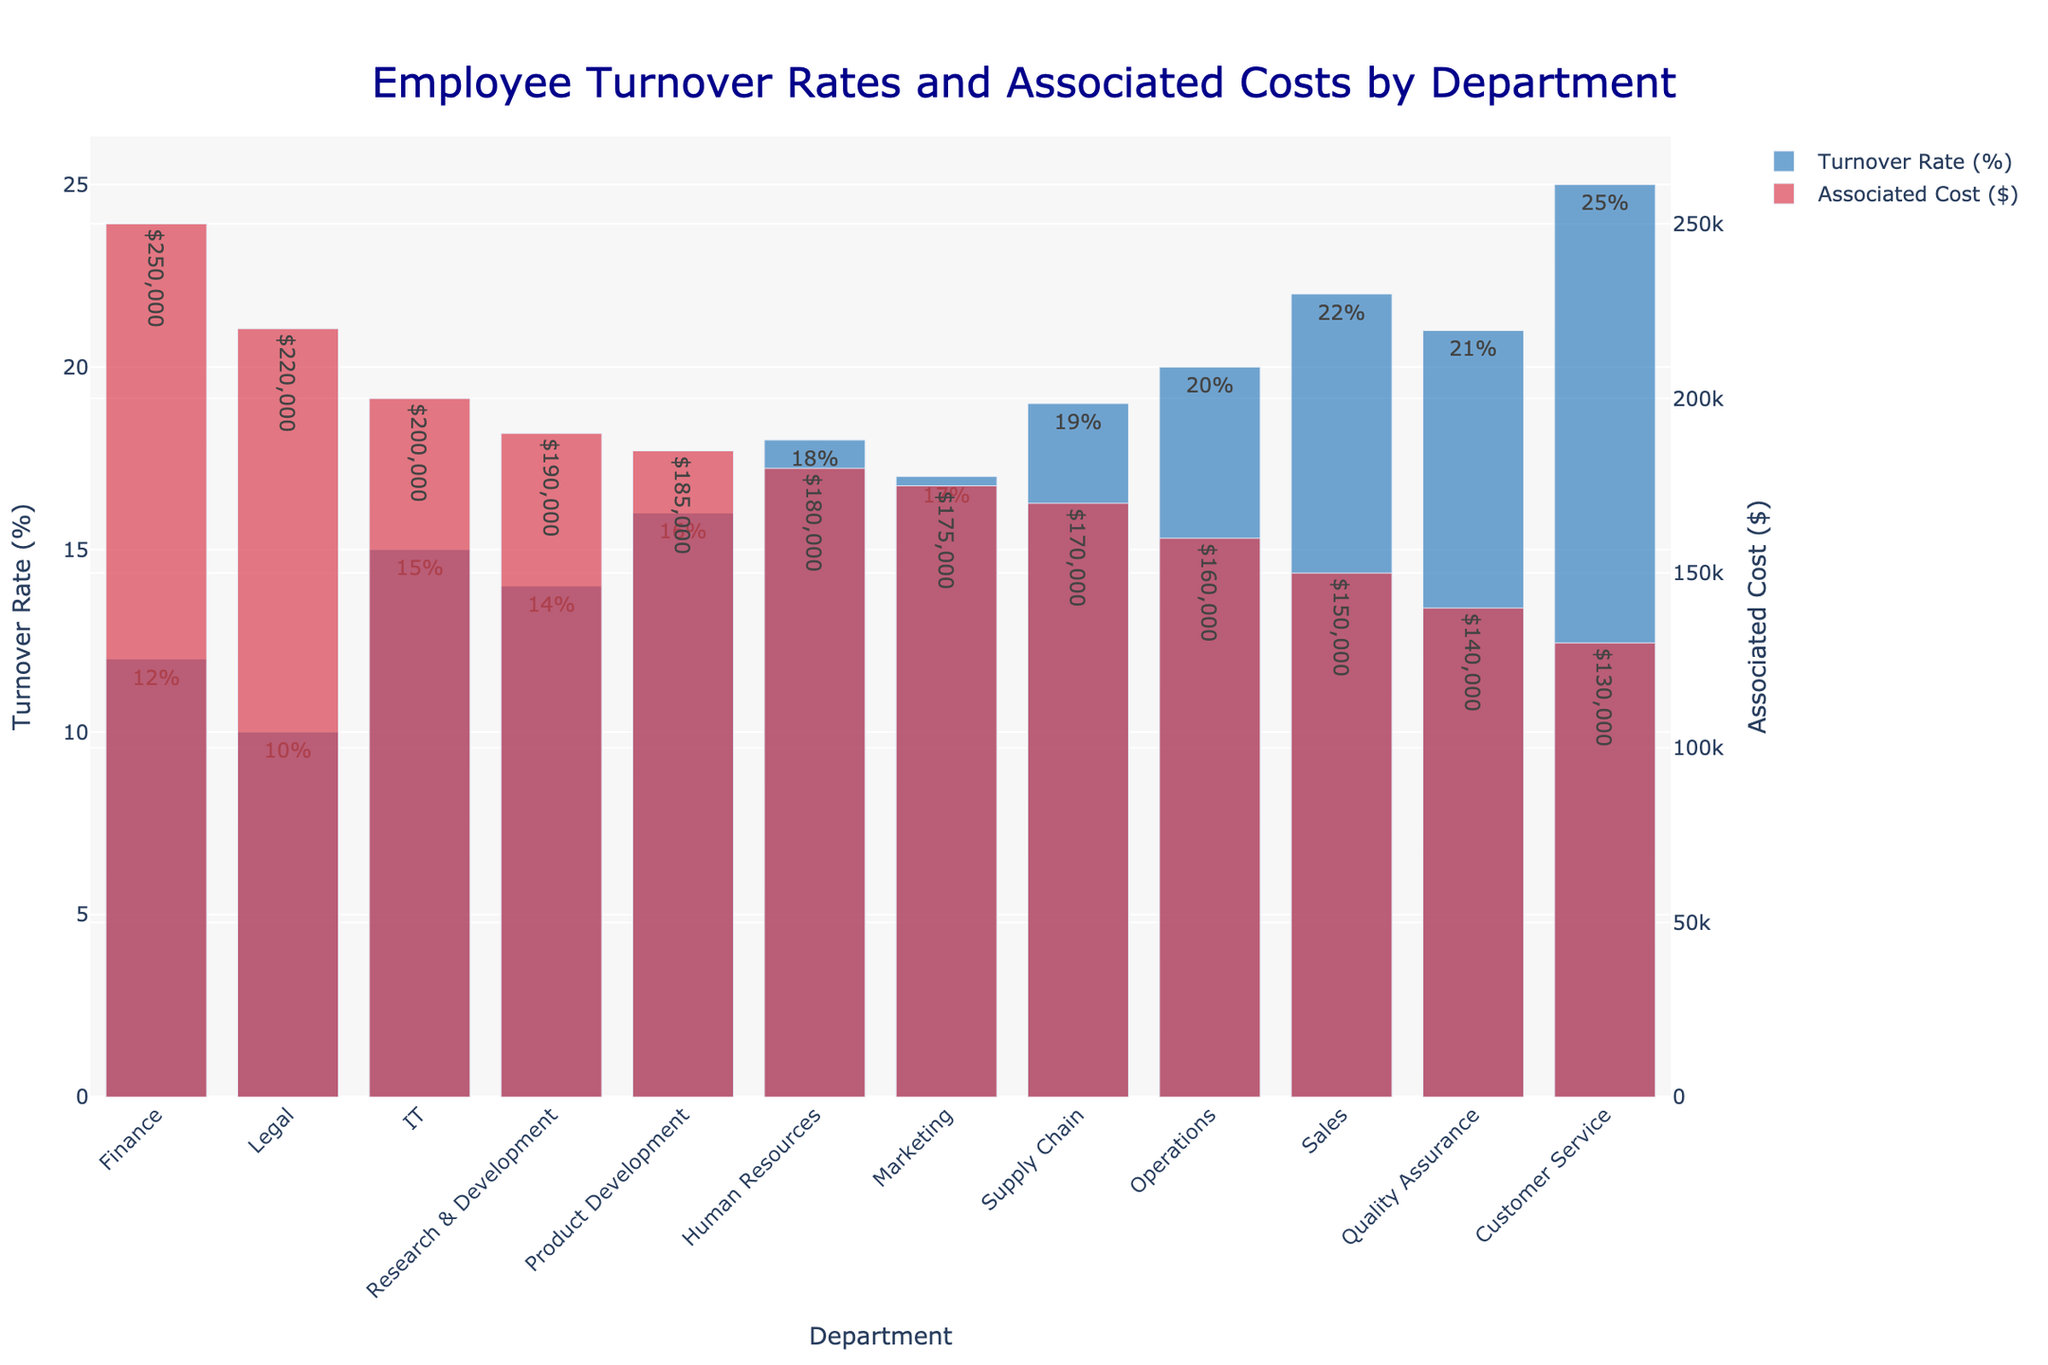What department has the highest turnover rate? Identify the department with the highest bar in the "Turnover Rate (%)" category. The highest bar corresponds to the Customer Service department.
Answer: Customer Service Which two departments have the largest difference in associated costs? Compare the bar heights and hovertext for all departments in the "Associated Cost ($)" category. The largest difference is between Finance and Customer Service.
Answer: Finance and Customer Service What is the average turnover rate across all departments? Add all the turnover rates together and then divide by the number of departments (12). The sum of turnover rates is 209%, and the average is 209% / 12.
Answer: 17.42% Which department has a lower associated cost but a higher turnover rate than the Marketing department? Identify departments with higher turnover rates but lower associated costs compared to Marketing (Turnover Rate: 17%, Cost: $175,000). Sales has a higher turnover rate (22%) and lower cost ($150,000).
Answer: Sales How much more is the associated cost for the Chief Financial Officer compared to the Chief Information Officer? Find the difference between the associated costs for CFO ($250,000) and CIO ($200,000). The difference is $250,000 - $200,000.
Answer: $50,000 Which department has a higher turnover rate, Operations or Supply Chain? Compare the bar heights and hovertext for Operations and Supply Chain in the "Turnover Rate (%)" category. Operations has a turnover rate of 20% while Supply Chain has 19%.
Answer: Operations How many departments have an associated cost greater than $180,000? Count the number of bars in the "Associated Cost ($)" category that exceed $180,000. The departments are Finance, IT, Legal, and R&D.
Answer: 4 Which position has the highest associated cost but also appears in the middle range for turnover rate? Look for the highest bar in the "Associated Cost ($)" category and find the corresponding turnover rate. Chief Financial Officer has the highest cost ($250,000) and a turnover rate of 12%, which is in the middle range.
Answer: Chief Financial Officer What is the total associated cost for Sales and Marketing combined? Sum the associated costs for Sales ($150,000) and Marketing ($175,000). The total is $150,000 + $175,000.
Answer: $325,000 Which two departments have the closest associated costs? Compare the bar heights in the "Associated Cost ($)" category and identify departments with smallest differences. Marketing ($175,000) and Supply Chain ($170,000) have the closest costs.
Answer: Marketing and Supply Chain 